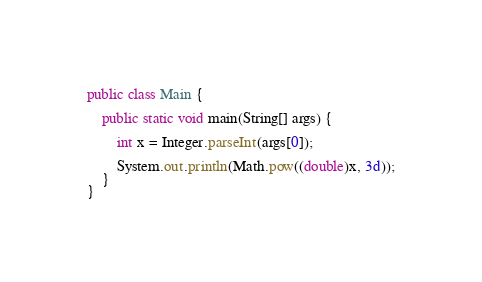<code> <loc_0><loc_0><loc_500><loc_500><_Java_>public class Main {

    public static void main(String[] args) {

        int x = Integer.parseInt(args[0]);

        System.out.println(Math.pow((double)x, 3d));
    }
}</code> 